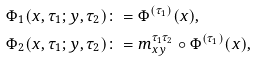Convert formula to latex. <formula><loc_0><loc_0><loc_500><loc_500>\Phi _ { 1 } ( x , \tau _ { 1 } ; y , \tau _ { 2 } ) & \colon = \Phi ^ { ( \tau _ { 1 } ) } ( x ) , \\ \Phi _ { 2 } ( x , \tau _ { 1 } ; y , \tau _ { 2 } ) & \colon = m _ { x y } ^ { \tau _ { 1 } \tau _ { 2 } } \circ \Phi ^ { ( \tau _ { 1 } ) } ( x ) ,</formula> 